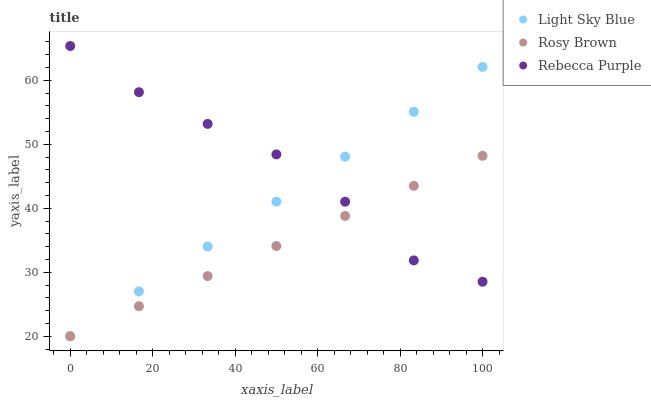Does Rosy Brown have the minimum area under the curve?
Answer yes or no. Yes. Does Rebecca Purple have the maximum area under the curve?
Answer yes or no. Yes. Does Light Sky Blue have the minimum area under the curve?
Answer yes or no. No. Does Light Sky Blue have the maximum area under the curve?
Answer yes or no. No. Is Rosy Brown the smoothest?
Answer yes or no. Yes. Is Rebecca Purple the roughest?
Answer yes or no. Yes. Is Light Sky Blue the smoothest?
Answer yes or no. No. Is Light Sky Blue the roughest?
Answer yes or no. No. Does Rosy Brown have the lowest value?
Answer yes or no. Yes. Does Rebecca Purple have the lowest value?
Answer yes or no. No. Does Rebecca Purple have the highest value?
Answer yes or no. Yes. Does Light Sky Blue have the highest value?
Answer yes or no. No. Does Rosy Brown intersect Light Sky Blue?
Answer yes or no. Yes. Is Rosy Brown less than Light Sky Blue?
Answer yes or no. No. Is Rosy Brown greater than Light Sky Blue?
Answer yes or no. No. 